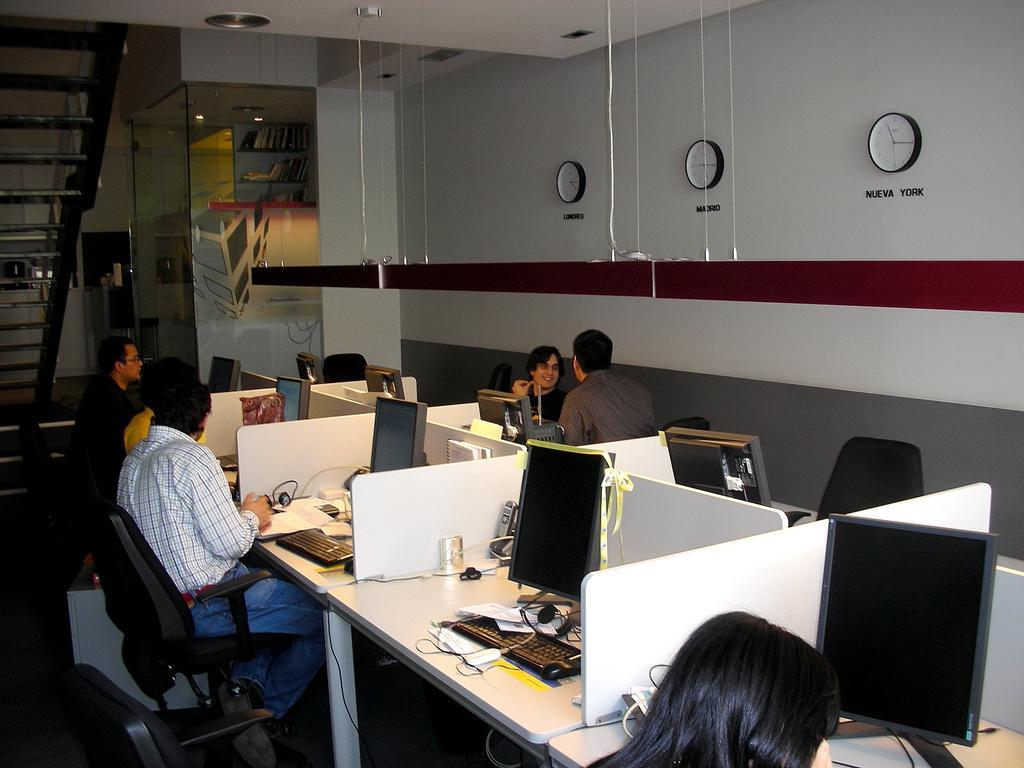Describe this image in one or two sentences. This picture is clicked in the office room. In this picture, we see men sitting on the chairs in their cabins. In front of them, we see a table on which monitors, keyboards and mouse are placed. The man in the brown shirt and the man in black T-shirt are talking to each other. Behind them, we see a wall in white and grey color. We see three wall clocks. On the left side, we see a staircase. At the top of the picture, we see the ceiling of the room. 